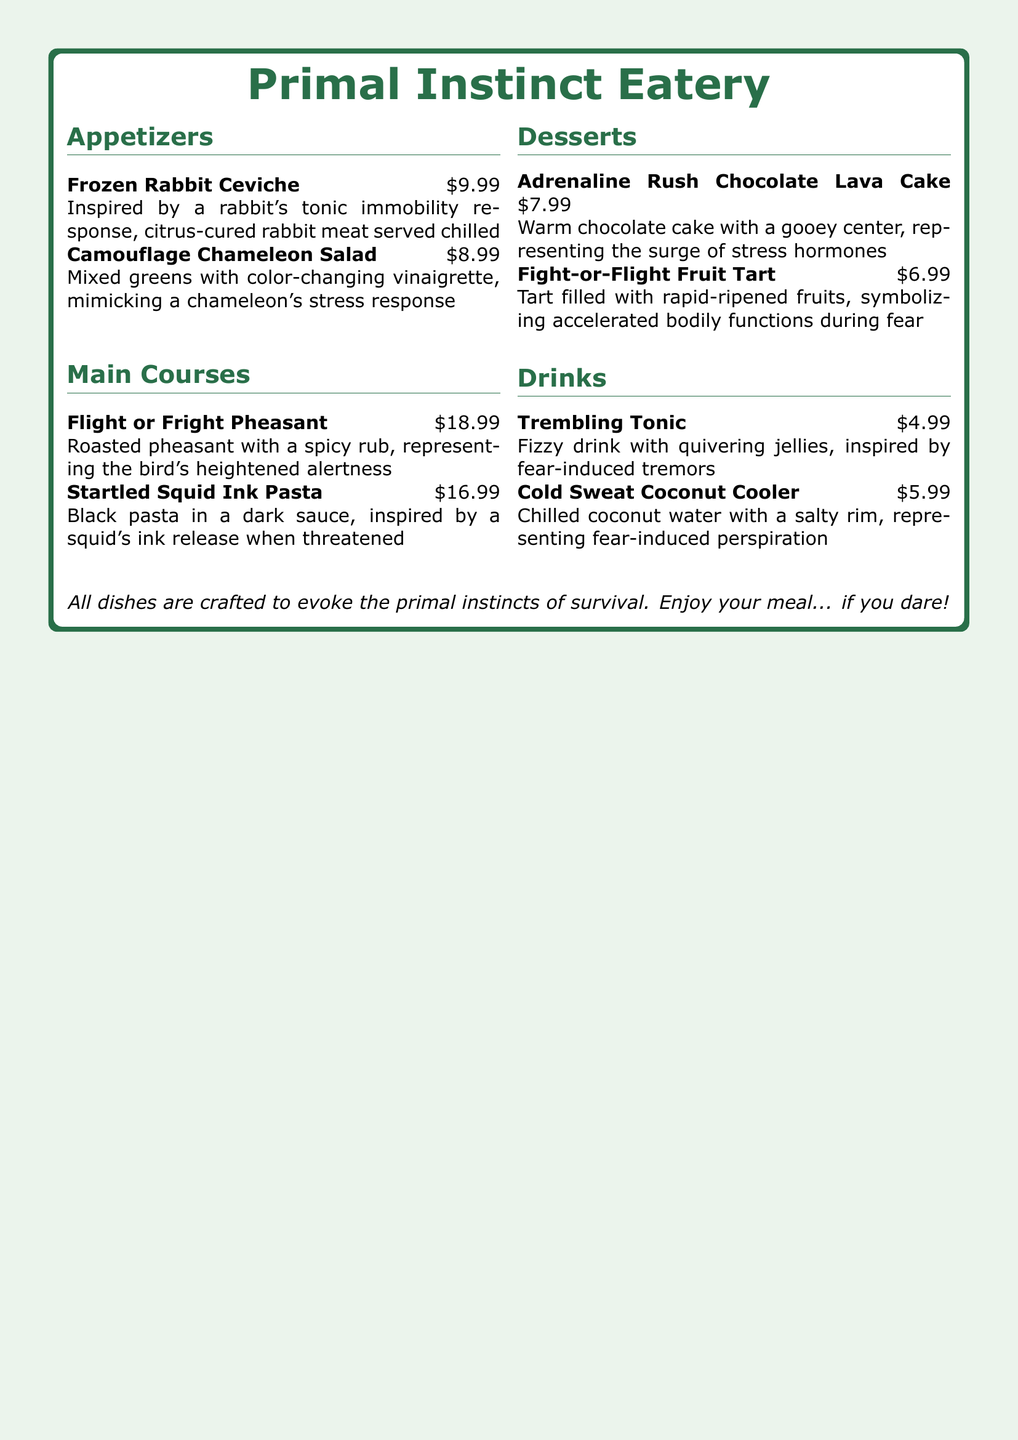what is the name of the restaurant? The name of the restaurant is prominently displayed at the top of the menu.
Answer: Primal Instinct Eatery how much is the Frozen Rabbit Ceviche? The price of the Frozen Rabbit Ceviche is listed under the appetizers section of the menu.
Answer: $9.99 what type of meat is used in the Flight or Fright Pheasant? The meat type is specified in the main courses section of the menu.
Answer: Pheasant what unique feature does the Camouflage Chameleon Salad have? The salad's vinaigrette mimics a specific animal's response, as noted in the description.
Answer: Color-changing what is the main ingredient of the Startled Squid Ink Pasta? The main ingredient is indicated in the title and description of this dish.
Answer: Squid ink what response does the Adrenaline Rush Chocolate Lava Cake represent? The cake symbolizes a physiological reaction indicated in its description.
Answer: Surge of stress hormones how much does the Cold Sweat Coconut Cooler cost? The price is located in the drinks section of the menu.
Answer: $5.99 which dessert symbolizes accelerated bodily functions during fear? This information is explicitly stated in the dessert descriptions.
Answer: Fight-or-Flight Fruit Tart what are the two drinks listed on the menu? The drink names are provided in the drinks section of the menu.
Answer: Trembling Tonic, Cold Sweat Coconut Cooler what is the description theme of the restaurant menu? The theme is indicated at the bottom of the menu, outlining the focus of the dishes.
Answer: Primal instincts of survival 